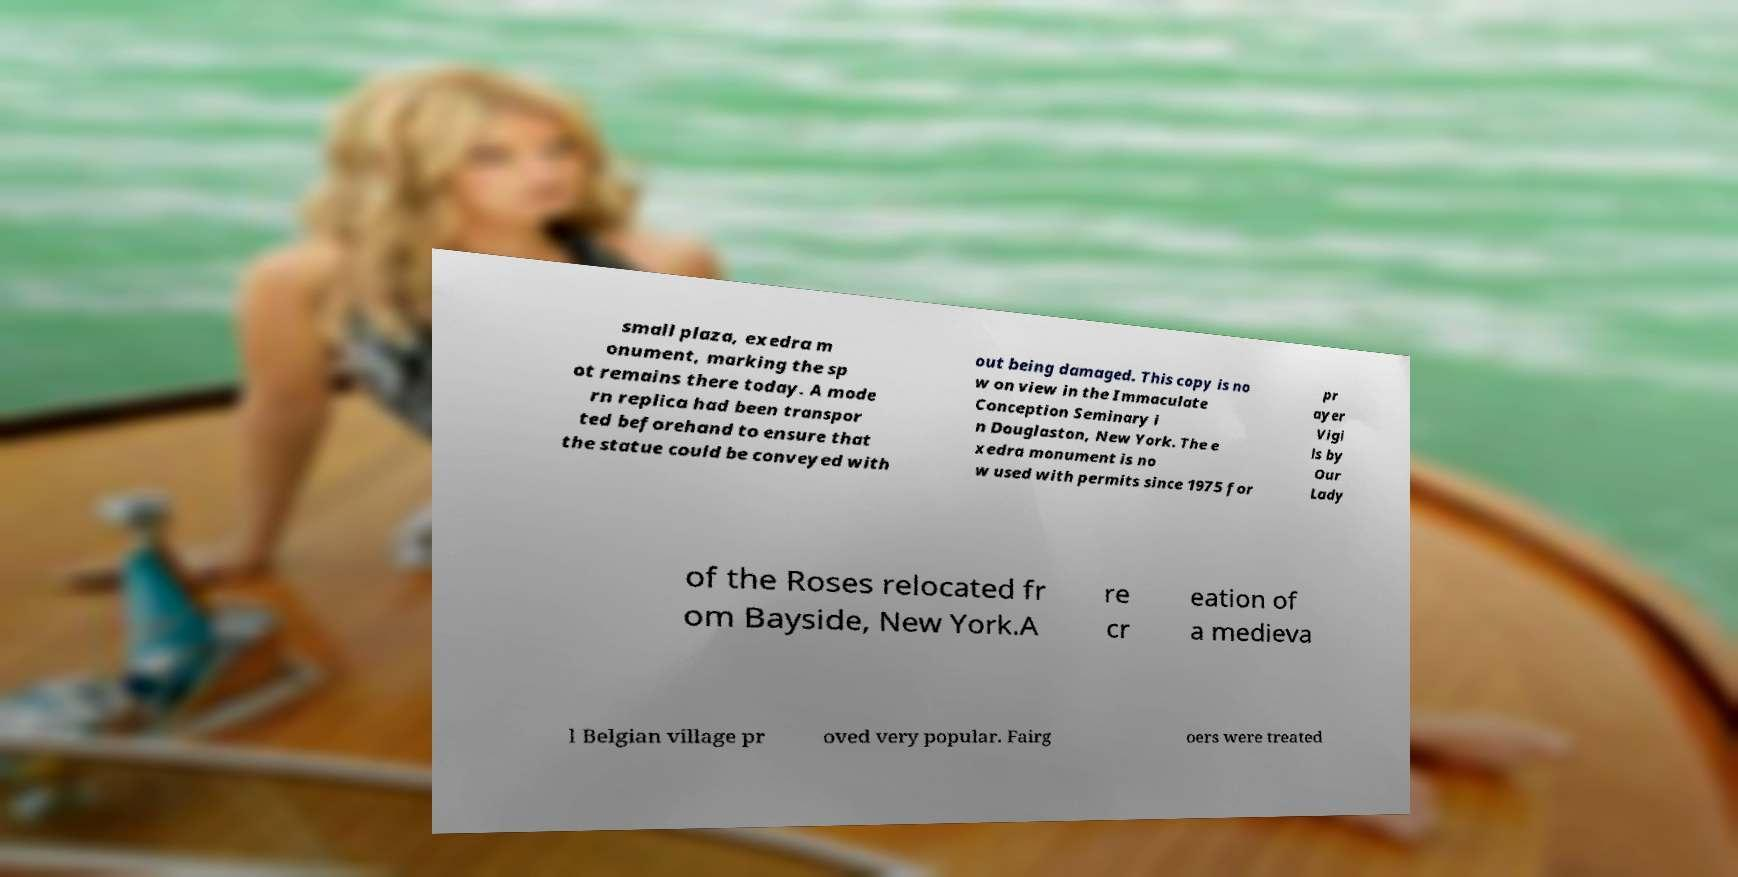Please read and relay the text visible in this image. What does it say? small plaza, exedra m onument, marking the sp ot remains there today. A mode rn replica had been transpor ted beforehand to ensure that the statue could be conveyed with out being damaged. This copy is no w on view in the Immaculate Conception Seminary i n Douglaston, New York. The e xedra monument is no w used with permits since 1975 for pr ayer Vigi ls by Our Lady of the Roses relocated fr om Bayside, New York.A re cr eation of a medieva l Belgian village pr oved very popular. Fairg oers were treated 